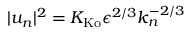Convert formula to latex. <formula><loc_0><loc_0><loc_500><loc_500>| u _ { n } | ^ { 2 } = K _ { K o } \epsilon ^ { 2 / 3 } k _ { n } ^ { - 2 / 3 }</formula> 